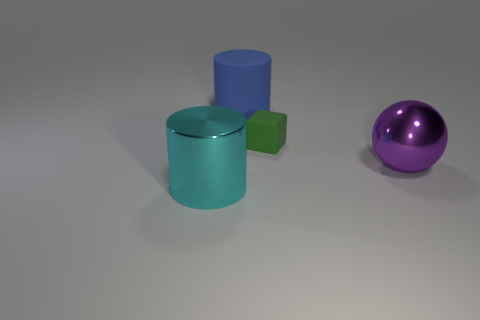Add 2 big metallic cylinders. How many objects exist? 6 Subtract all blocks. How many objects are left? 3 Subtract 0 green cylinders. How many objects are left? 4 Subtract all metal cylinders. Subtract all big cylinders. How many objects are left? 1 Add 2 big matte cylinders. How many big matte cylinders are left? 3 Add 3 small blocks. How many small blocks exist? 4 